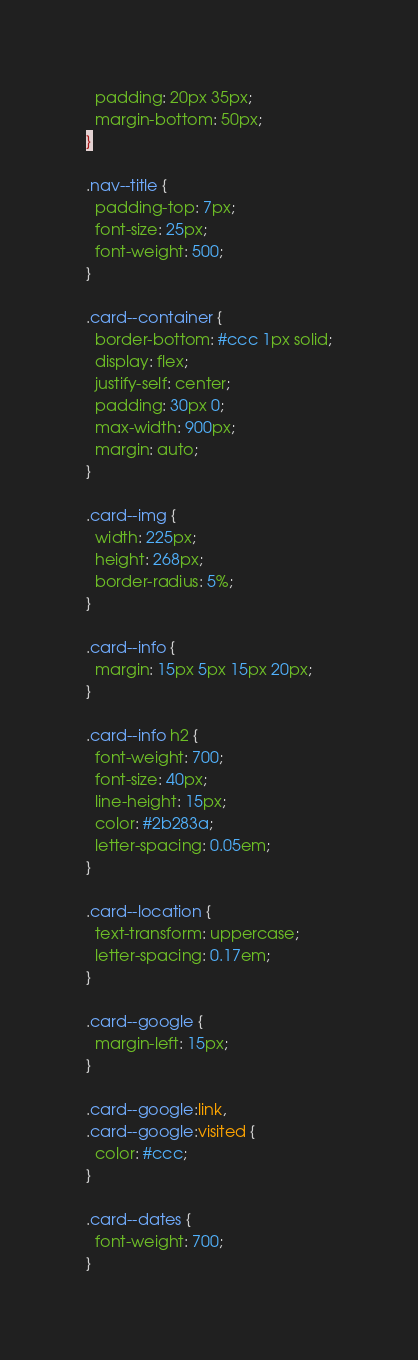Convert code to text. <code><loc_0><loc_0><loc_500><loc_500><_CSS_>  padding: 20px 35px;
  margin-bottom: 50px;
}

.nav--title {
  padding-top: 7px;
  font-size: 25px;
  font-weight: 500;
}

.card--container {
  border-bottom: #ccc 1px solid;
  display: flex;
  justify-self: center;
  padding: 30px 0;
  max-width: 900px;
  margin: auto;
}

.card--img {
  width: 225px;
  height: 268px;
  border-radius: 5%;
}

.card--info {
  margin: 15px 5px 15px 20px;
}

.card--info h2 {
  font-weight: 700;
  font-size: 40px;
  line-height: 15px;
  color: #2b283a;
  letter-spacing: 0.05em;
}

.card--location {
  text-transform: uppercase;
  letter-spacing: 0.17em;
}

.card--google {
  margin-left: 15px;
}

.card--google:link,
.card--google:visited {
  color: #ccc;
}

.card--dates {
  font-weight: 700;
}
</code> 